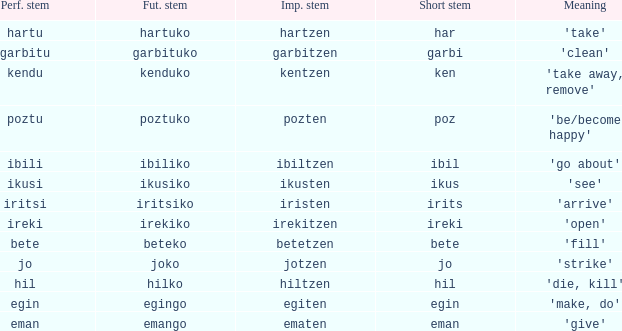What is the number for future stem for poztu? 1.0. 